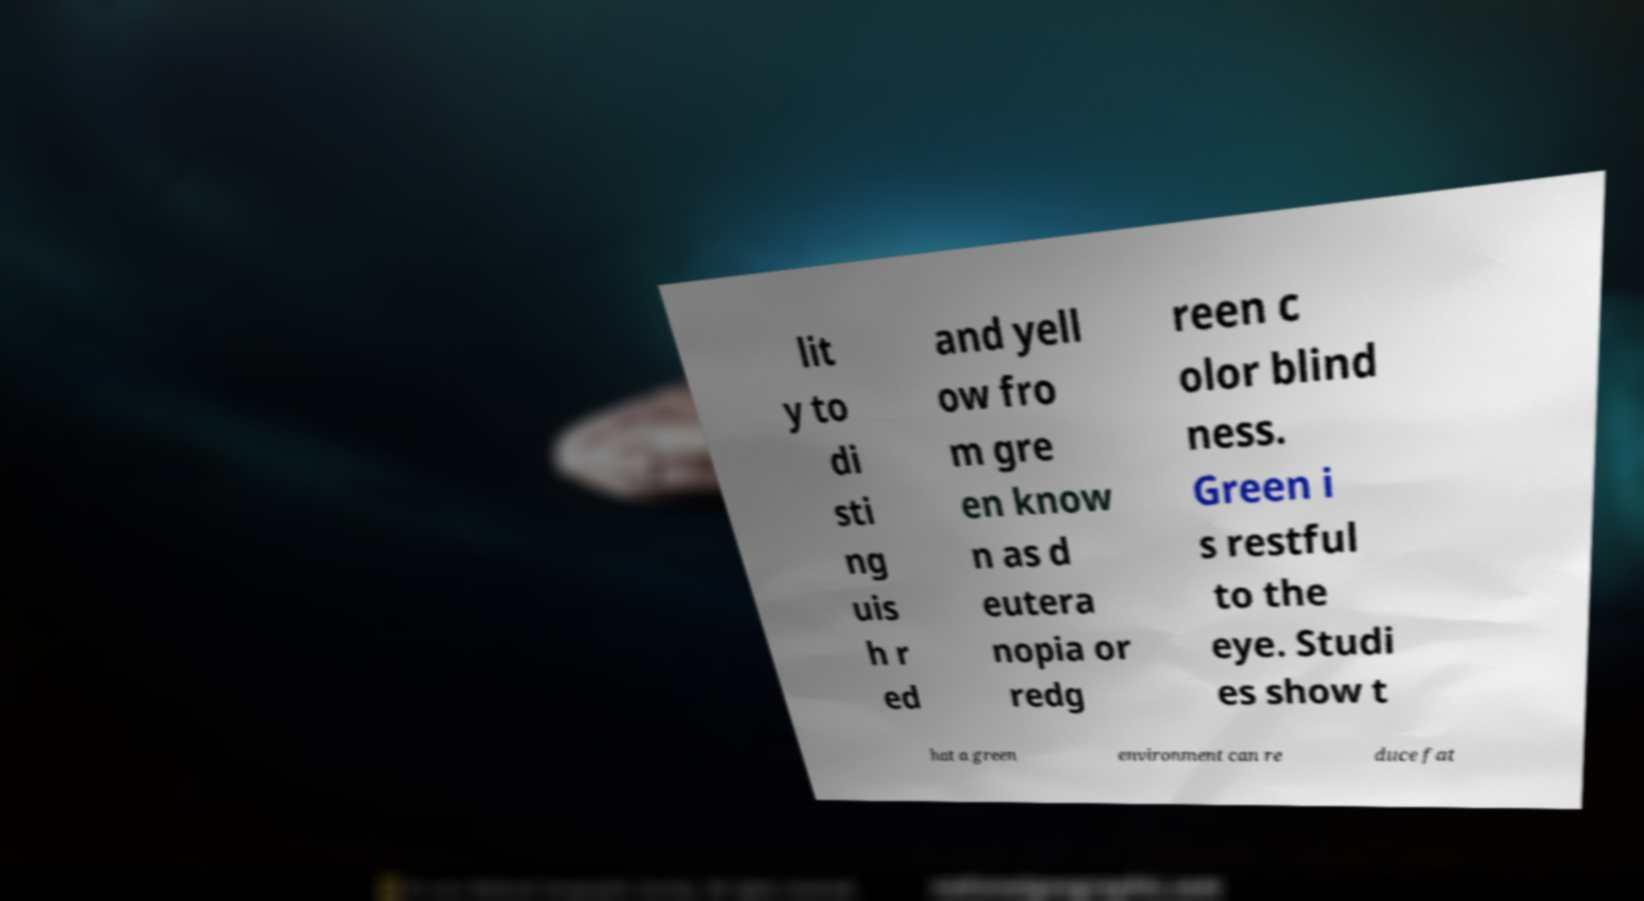For documentation purposes, I need the text within this image transcribed. Could you provide that? lit y to di sti ng uis h r ed and yell ow fro m gre en know n as d eutera nopia or redg reen c olor blind ness. Green i s restful to the eye. Studi es show t hat a green environment can re duce fat 